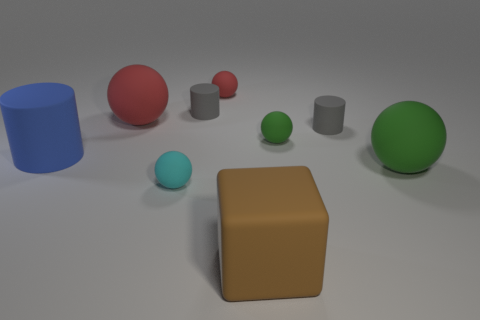Is there any other thing that has the same shape as the brown rubber object?
Provide a succinct answer. No. What is the shape of the big green object?
Ensure brevity in your answer.  Sphere. What shape is the blue thing that is the same size as the block?
Keep it short and to the point. Cylinder. Are there any objects that have the same size as the block?
Offer a terse response. Yes. There is a brown thing that is the same size as the blue cylinder; what is it made of?
Keep it short and to the point. Rubber. What size is the gray cylinder that is on the right side of the small gray matte thing that is to the left of the brown matte object?
Give a very brief answer. Small. Is the size of the gray matte cylinder to the left of the rubber cube the same as the small cyan ball?
Give a very brief answer. Yes. Are there more big things that are in front of the blue matte cylinder than small gray rubber things on the left side of the tiny cyan rubber ball?
Provide a succinct answer. Yes. What shape is the big thing that is right of the large blue rubber cylinder and behind the big green rubber thing?
Give a very brief answer. Sphere. What is the shape of the brown object in front of the cyan rubber sphere?
Give a very brief answer. Cube. 